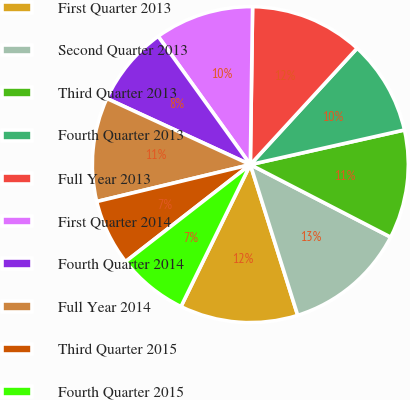Convert chart to OTSL. <chart><loc_0><loc_0><loc_500><loc_500><pie_chart><fcel>First Quarter 2013<fcel>Second Quarter 2013<fcel>Third Quarter 2013<fcel>Fourth Quarter 2013<fcel>Full Year 2013<fcel>First Quarter 2014<fcel>Fourth Quarter 2014<fcel>Full Year 2014<fcel>Third Quarter 2015<fcel>Fourth Quarter 2015<nl><fcel>12.08%<fcel>12.56%<fcel>11.11%<fcel>9.66%<fcel>11.59%<fcel>10.14%<fcel>8.21%<fcel>10.63%<fcel>6.76%<fcel>7.25%<nl></chart> 